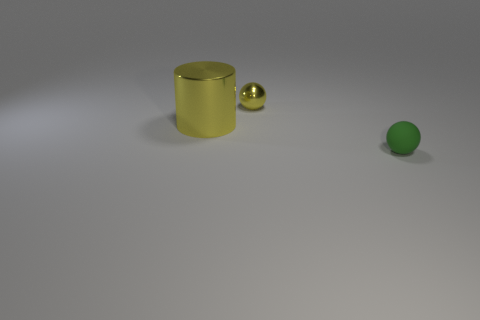What size is the ball that is the same color as the large object?
Give a very brief answer. Small. Does the big metal object have the same color as the metal thing that is to the right of the big yellow metallic object?
Keep it short and to the point. Yes. There is a object that is in front of the yellow shiny sphere and right of the yellow cylinder; what material is it?
Offer a very short reply. Rubber. Is the size of the green thing the same as the thing that is behind the cylinder?
Your response must be concise. Yes. How many other objects are there of the same color as the matte thing?
Ensure brevity in your answer.  0. Are there more tiny metallic spheres that are to the left of the large yellow cylinder than large cylinders?
Keep it short and to the point. No. What is the color of the tiny sphere behind the yellow metallic thing in front of the shiny thing that is right of the cylinder?
Give a very brief answer. Yellow. Do the green object and the small yellow thing have the same material?
Keep it short and to the point. No. Is there a object of the same size as the green ball?
Your answer should be compact. Yes. There is a green thing that is the same size as the metallic ball; what material is it?
Your response must be concise. Rubber. 